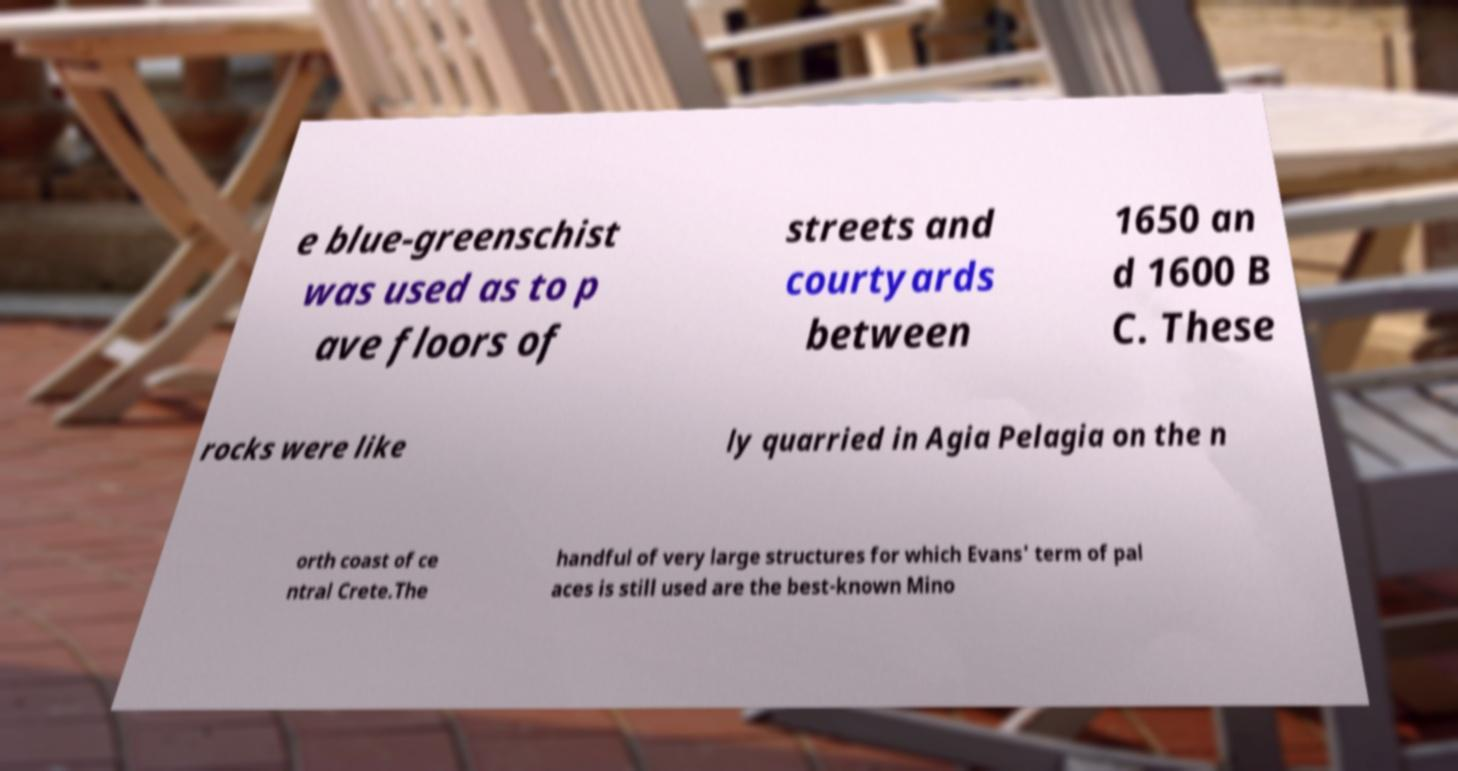Please identify and transcribe the text found in this image. e blue-greenschist was used as to p ave floors of streets and courtyards between 1650 an d 1600 B C. These rocks were like ly quarried in Agia Pelagia on the n orth coast of ce ntral Crete.The handful of very large structures for which Evans' term of pal aces is still used are the best-known Mino 